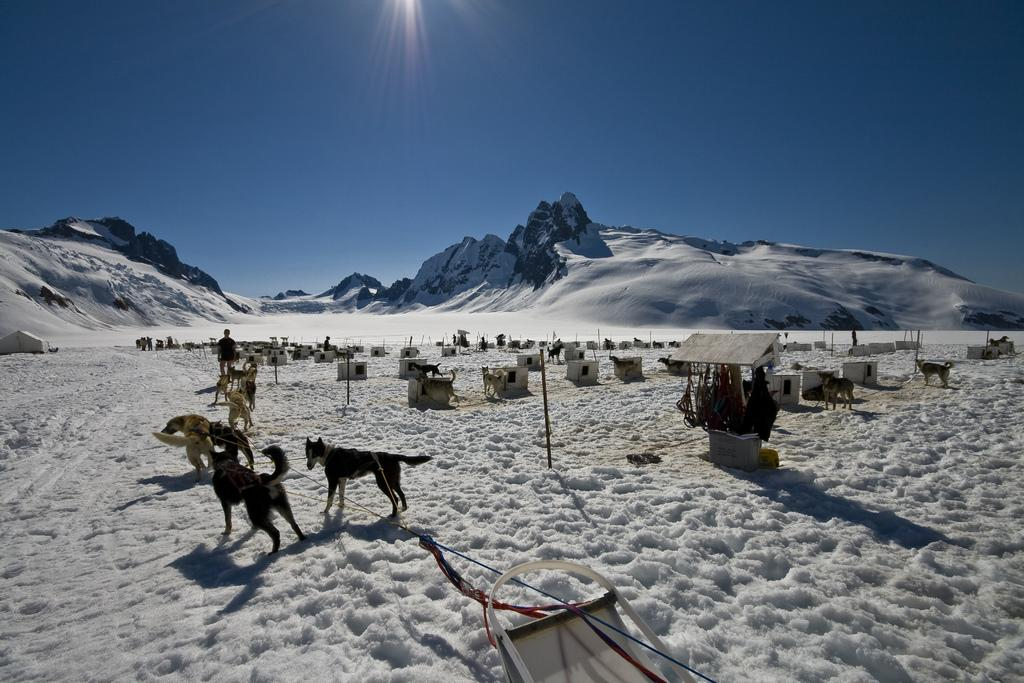What types of living organisms can be seen in the image? There are animals in the image. What structures are present in the image? There are poles and a tent in the image. Who is present in the image? There is a person in the image. What is the terrain like in the image? The land is covered with snow, and there are hills in the image. What is the color of the sky in the image? The sky is blue in the image. Can you describe any other objects in the image? There are objects in the image, but their specific nature is not mentioned in the provided facts. Where is the berry located in the image? There is no berry present in the image. What type of umbrella is being used by the person in the image? There is no umbrella present in the image. 